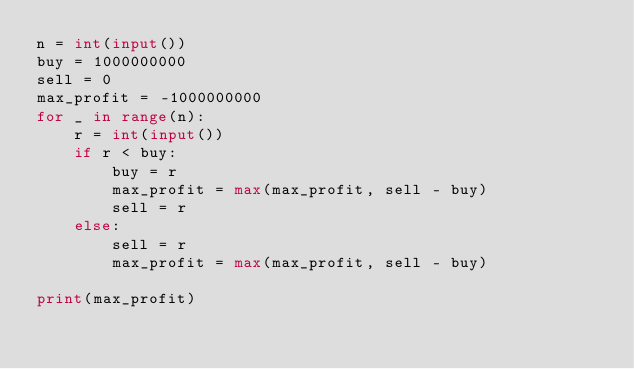<code> <loc_0><loc_0><loc_500><loc_500><_Python_>n = int(input())
buy = 1000000000
sell = 0
max_profit = -1000000000
for _ in range(n):
    r = int(input())
    if r < buy:
        buy = r
        max_profit = max(max_profit, sell - buy)
        sell = r
    else:
        sell = r
        max_profit = max(max_profit, sell - buy)

print(max_profit)
    
</code> 